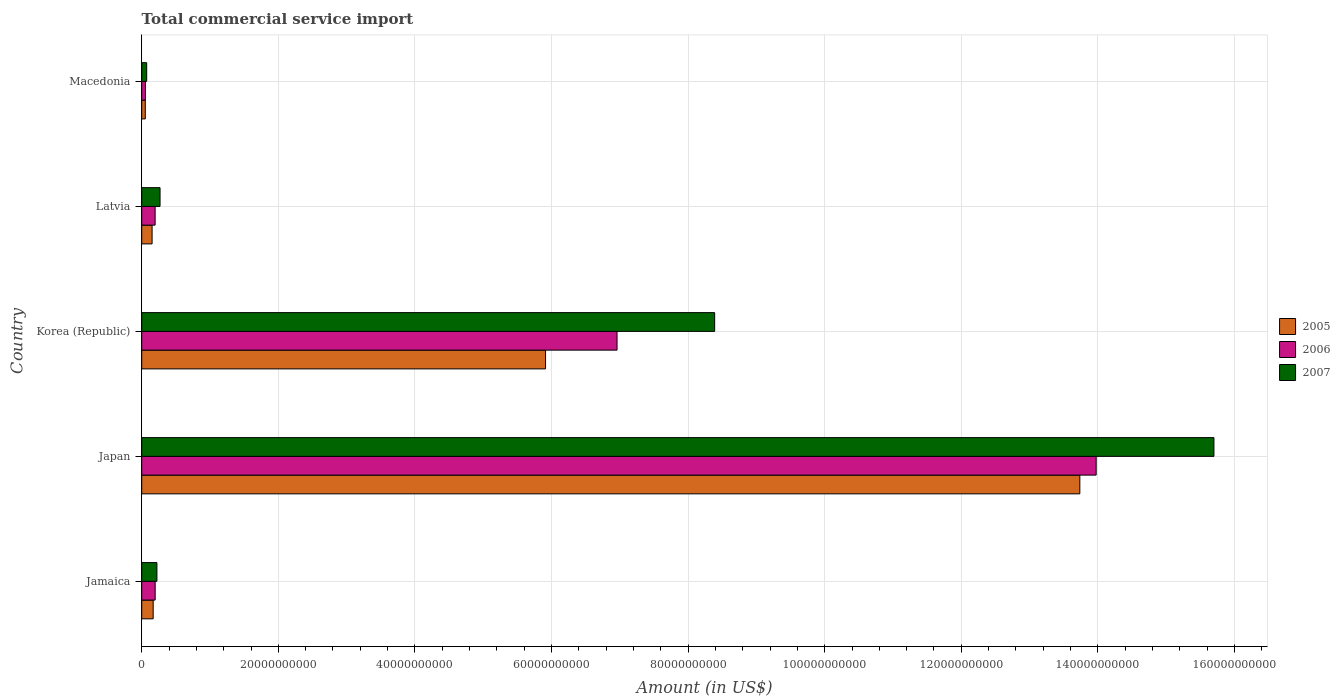How many different coloured bars are there?
Your response must be concise. 3. How many groups of bars are there?
Provide a short and direct response. 5. What is the label of the 4th group of bars from the top?
Provide a short and direct response. Japan. In how many cases, is the number of bars for a given country not equal to the number of legend labels?
Offer a very short reply. 0. What is the total commercial service import in 2006 in Latvia?
Offer a terse response. 1.96e+09. Across all countries, what is the maximum total commercial service import in 2007?
Your answer should be very brief. 1.57e+11. Across all countries, what is the minimum total commercial service import in 2006?
Offer a very short reply. 5.38e+08. In which country was the total commercial service import in 2006 minimum?
Your answer should be compact. Macedonia. What is the total total commercial service import in 2005 in the graph?
Offer a very short reply. 2.00e+11. What is the difference between the total commercial service import in 2007 in Latvia and that in Macedonia?
Keep it short and to the point. 1.95e+09. What is the difference between the total commercial service import in 2007 in Jamaica and the total commercial service import in 2005 in Korea (Republic)?
Provide a succinct answer. -5.69e+1. What is the average total commercial service import in 2007 per country?
Offer a terse response. 4.93e+1. What is the difference between the total commercial service import in 2006 and total commercial service import in 2005 in Jamaica?
Provide a succinct answer. 2.94e+08. In how many countries, is the total commercial service import in 2005 greater than 76000000000 US$?
Your answer should be compact. 1. What is the ratio of the total commercial service import in 2007 in Japan to that in Latvia?
Give a very brief answer. 58.53. Is the difference between the total commercial service import in 2006 in Jamaica and Latvia greater than the difference between the total commercial service import in 2005 in Jamaica and Latvia?
Provide a succinct answer. No. What is the difference between the highest and the second highest total commercial service import in 2005?
Offer a terse response. 7.82e+1. What is the difference between the highest and the lowest total commercial service import in 2005?
Your answer should be very brief. 1.37e+11. In how many countries, is the total commercial service import in 2006 greater than the average total commercial service import in 2006 taken over all countries?
Your answer should be very brief. 2. Is the sum of the total commercial service import in 2006 in Jamaica and Korea (Republic) greater than the maximum total commercial service import in 2007 across all countries?
Offer a terse response. No. Are all the bars in the graph horizontal?
Keep it short and to the point. Yes. How many countries are there in the graph?
Your answer should be compact. 5. What is the difference between two consecutive major ticks on the X-axis?
Offer a very short reply. 2.00e+1. Are the values on the major ticks of X-axis written in scientific E-notation?
Provide a short and direct response. No. Does the graph contain any zero values?
Make the answer very short. No. How many legend labels are there?
Ensure brevity in your answer.  3. What is the title of the graph?
Your answer should be compact. Total commercial service import. Does "1961" appear as one of the legend labels in the graph?
Your answer should be very brief. No. What is the label or title of the X-axis?
Your answer should be very brief. Amount (in US$). What is the Amount (in US$) in 2005 in Jamaica?
Your response must be concise. 1.68e+09. What is the Amount (in US$) in 2006 in Jamaica?
Ensure brevity in your answer.  1.97e+09. What is the Amount (in US$) of 2007 in Jamaica?
Your response must be concise. 2.23e+09. What is the Amount (in US$) of 2005 in Japan?
Offer a very short reply. 1.37e+11. What is the Amount (in US$) of 2006 in Japan?
Give a very brief answer. 1.40e+11. What is the Amount (in US$) in 2007 in Japan?
Offer a terse response. 1.57e+11. What is the Amount (in US$) in 2005 in Korea (Republic)?
Provide a short and direct response. 5.91e+1. What is the Amount (in US$) in 2006 in Korea (Republic)?
Provide a succinct answer. 6.96e+1. What is the Amount (in US$) in 2007 in Korea (Republic)?
Offer a very short reply. 8.39e+1. What is the Amount (in US$) of 2005 in Latvia?
Ensure brevity in your answer.  1.52e+09. What is the Amount (in US$) of 2006 in Latvia?
Offer a terse response. 1.96e+09. What is the Amount (in US$) of 2007 in Latvia?
Keep it short and to the point. 2.68e+09. What is the Amount (in US$) in 2005 in Macedonia?
Your response must be concise. 5.23e+08. What is the Amount (in US$) in 2006 in Macedonia?
Make the answer very short. 5.38e+08. What is the Amount (in US$) of 2007 in Macedonia?
Your response must be concise. 7.27e+08. Across all countries, what is the maximum Amount (in US$) in 2005?
Offer a very short reply. 1.37e+11. Across all countries, what is the maximum Amount (in US$) in 2006?
Your answer should be compact. 1.40e+11. Across all countries, what is the maximum Amount (in US$) in 2007?
Ensure brevity in your answer.  1.57e+11. Across all countries, what is the minimum Amount (in US$) of 2005?
Your answer should be compact. 5.23e+08. Across all countries, what is the minimum Amount (in US$) in 2006?
Offer a terse response. 5.38e+08. Across all countries, what is the minimum Amount (in US$) in 2007?
Offer a terse response. 7.27e+08. What is the total Amount (in US$) of 2005 in the graph?
Offer a terse response. 2.00e+11. What is the total Amount (in US$) in 2006 in the graph?
Give a very brief answer. 2.14e+11. What is the total Amount (in US$) in 2007 in the graph?
Provide a short and direct response. 2.47e+11. What is the difference between the Amount (in US$) in 2005 in Jamaica and that in Japan?
Your answer should be very brief. -1.36e+11. What is the difference between the Amount (in US$) in 2006 in Jamaica and that in Japan?
Your answer should be very brief. -1.38e+11. What is the difference between the Amount (in US$) in 2007 in Jamaica and that in Japan?
Your answer should be compact. -1.55e+11. What is the difference between the Amount (in US$) of 2005 in Jamaica and that in Korea (Republic)?
Offer a terse response. -5.75e+1. What is the difference between the Amount (in US$) of 2006 in Jamaica and that in Korea (Republic)?
Your response must be concise. -6.76e+1. What is the difference between the Amount (in US$) in 2007 in Jamaica and that in Korea (Republic)?
Offer a terse response. -8.17e+1. What is the difference between the Amount (in US$) in 2005 in Jamaica and that in Latvia?
Give a very brief answer. 1.56e+08. What is the difference between the Amount (in US$) of 2006 in Jamaica and that in Latvia?
Ensure brevity in your answer.  7.28e+06. What is the difference between the Amount (in US$) of 2007 in Jamaica and that in Latvia?
Offer a terse response. -4.57e+08. What is the difference between the Amount (in US$) in 2005 in Jamaica and that in Macedonia?
Give a very brief answer. 1.15e+09. What is the difference between the Amount (in US$) in 2006 in Jamaica and that in Macedonia?
Keep it short and to the point. 1.43e+09. What is the difference between the Amount (in US$) of 2007 in Jamaica and that in Macedonia?
Give a very brief answer. 1.50e+09. What is the difference between the Amount (in US$) in 2005 in Japan and that in Korea (Republic)?
Your response must be concise. 7.82e+1. What is the difference between the Amount (in US$) in 2006 in Japan and that in Korea (Republic)?
Your response must be concise. 7.02e+1. What is the difference between the Amount (in US$) in 2007 in Japan and that in Korea (Republic)?
Your answer should be compact. 7.31e+1. What is the difference between the Amount (in US$) in 2005 in Japan and that in Latvia?
Your answer should be very brief. 1.36e+11. What is the difference between the Amount (in US$) of 2006 in Japan and that in Latvia?
Make the answer very short. 1.38e+11. What is the difference between the Amount (in US$) of 2007 in Japan and that in Latvia?
Your answer should be very brief. 1.54e+11. What is the difference between the Amount (in US$) in 2005 in Japan and that in Macedonia?
Keep it short and to the point. 1.37e+11. What is the difference between the Amount (in US$) in 2006 in Japan and that in Macedonia?
Offer a terse response. 1.39e+11. What is the difference between the Amount (in US$) of 2007 in Japan and that in Macedonia?
Keep it short and to the point. 1.56e+11. What is the difference between the Amount (in US$) in 2005 in Korea (Republic) and that in Latvia?
Provide a short and direct response. 5.76e+1. What is the difference between the Amount (in US$) in 2006 in Korea (Republic) and that in Latvia?
Offer a very short reply. 6.76e+1. What is the difference between the Amount (in US$) in 2007 in Korea (Republic) and that in Latvia?
Provide a short and direct response. 8.12e+1. What is the difference between the Amount (in US$) in 2005 in Korea (Republic) and that in Macedonia?
Your answer should be very brief. 5.86e+1. What is the difference between the Amount (in US$) of 2006 in Korea (Republic) and that in Macedonia?
Ensure brevity in your answer.  6.91e+1. What is the difference between the Amount (in US$) of 2007 in Korea (Republic) and that in Macedonia?
Ensure brevity in your answer.  8.32e+1. What is the difference between the Amount (in US$) in 2005 in Latvia and that in Macedonia?
Provide a succinct answer. 9.97e+08. What is the difference between the Amount (in US$) of 2006 in Latvia and that in Macedonia?
Offer a terse response. 1.42e+09. What is the difference between the Amount (in US$) in 2007 in Latvia and that in Macedonia?
Offer a very short reply. 1.95e+09. What is the difference between the Amount (in US$) in 2005 in Jamaica and the Amount (in US$) in 2006 in Japan?
Make the answer very short. -1.38e+11. What is the difference between the Amount (in US$) in 2005 in Jamaica and the Amount (in US$) in 2007 in Japan?
Offer a very short reply. -1.55e+11. What is the difference between the Amount (in US$) in 2006 in Jamaica and the Amount (in US$) in 2007 in Japan?
Offer a terse response. -1.55e+11. What is the difference between the Amount (in US$) of 2005 in Jamaica and the Amount (in US$) of 2006 in Korea (Republic)?
Your answer should be very brief. -6.79e+1. What is the difference between the Amount (in US$) in 2005 in Jamaica and the Amount (in US$) in 2007 in Korea (Republic)?
Your response must be concise. -8.22e+1. What is the difference between the Amount (in US$) in 2006 in Jamaica and the Amount (in US$) in 2007 in Korea (Republic)?
Your response must be concise. -8.19e+1. What is the difference between the Amount (in US$) of 2005 in Jamaica and the Amount (in US$) of 2006 in Latvia?
Your answer should be compact. -2.87e+08. What is the difference between the Amount (in US$) in 2005 in Jamaica and the Amount (in US$) in 2007 in Latvia?
Your answer should be very brief. -1.01e+09. What is the difference between the Amount (in US$) in 2006 in Jamaica and the Amount (in US$) in 2007 in Latvia?
Your answer should be very brief. -7.13e+08. What is the difference between the Amount (in US$) in 2005 in Jamaica and the Amount (in US$) in 2006 in Macedonia?
Provide a succinct answer. 1.14e+09. What is the difference between the Amount (in US$) in 2005 in Jamaica and the Amount (in US$) in 2007 in Macedonia?
Provide a short and direct response. 9.48e+08. What is the difference between the Amount (in US$) of 2006 in Jamaica and the Amount (in US$) of 2007 in Macedonia?
Keep it short and to the point. 1.24e+09. What is the difference between the Amount (in US$) in 2005 in Japan and the Amount (in US$) in 2006 in Korea (Republic)?
Ensure brevity in your answer.  6.78e+1. What is the difference between the Amount (in US$) of 2005 in Japan and the Amount (in US$) of 2007 in Korea (Republic)?
Provide a succinct answer. 5.35e+1. What is the difference between the Amount (in US$) of 2006 in Japan and the Amount (in US$) of 2007 in Korea (Republic)?
Ensure brevity in your answer.  5.59e+1. What is the difference between the Amount (in US$) in 2005 in Japan and the Amount (in US$) in 2006 in Latvia?
Your answer should be very brief. 1.35e+11. What is the difference between the Amount (in US$) of 2005 in Japan and the Amount (in US$) of 2007 in Latvia?
Provide a succinct answer. 1.35e+11. What is the difference between the Amount (in US$) of 2006 in Japan and the Amount (in US$) of 2007 in Latvia?
Ensure brevity in your answer.  1.37e+11. What is the difference between the Amount (in US$) of 2005 in Japan and the Amount (in US$) of 2006 in Macedonia?
Make the answer very short. 1.37e+11. What is the difference between the Amount (in US$) of 2005 in Japan and the Amount (in US$) of 2007 in Macedonia?
Your answer should be compact. 1.37e+11. What is the difference between the Amount (in US$) of 2006 in Japan and the Amount (in US$) of 2007 in Macedonia?
Provide a short and direct response. 1.39e+11. What is the difference between the Amount (in US$) of 2005 in Korea (Republic) and the Amount (in US$) of 2006 in Latvia?
Your answer should be compact. 5.72e+1. What is the difference between the Amount (in US$) in 2005 in Korea (Republic) and the Amount (in US$) in 2007 in Latvia?
Your response must be concise. 5.64e+1. What is the difference between the Amount (in US$) in 2006 in Korea (Republic) and the Amount (in US$) in 2007 in Latvia?
Provide a succinct answer. 6.69e+1. What is the difference between the Amount (in US$) of 2005 in Korea (Republic) and the Amount (in US$) of 2006 in Macedonia?
Offer a terse response. 5.86e+1. What is the difference between the Amount (in US$) in 2005 in Korea (Republic) and the Amount (in US$) in 2007 in Macedonia?
Give a very brief answer. 5.84e+1. What is the difference between the Amount (in US$) of 2006 in Korea (Republic) and the Amount (in US$) of 2007 in Macedonia?
Give a very brief answer. 6.89e+1. What is the difference between the Amount (in US$) in 2005 in Latvia and the Amount (in US$) in 2006 in Macedonia?
Offer a terse response. 9.81e+08. What is the difference between the Amount (in US$) of 2005 in Latvia and the Amount (in US$) of 2007 in Macedonia?
Offer a terse response. 7.92e+08. What is the difference between the Amount (in US$) of 2006 in Latvia and the Amount (in US$) of 2007 in Macedonia?
Your answer should be very brief. 1.23e+09. What is the average Amount (in US$) in 2005 per country?
Ensure brevity in your answer.  4.00e+1. What is the average Amount (in US$) in 2006 per country?
Provide a short and direct response. 4.28e+1. What is the average Amount (in US$) of 2007 per country?
Your answer should be very brief. 4.93e+1. What is the difference between the Amount (in US$) in 2005 and Amount (in US$) in 2006 in Jamaica?
Your response must be concise. -2.94e+08. What is the difference between the Amount (in US$) in 2005 and Amount (in US$) in 2007 in Jamaica?
Offer a terse response. -5.50e+08. What is the difference between the Amount (in US$) in 2006 and Amount (in US$) in 2007 in Jamaica?
Offer a very short reply. -2.56e+08. What is the difference between the Amount (in US$) of 2005 and Amount (in US$) of 2006 in Japan?
Give a very brief answer. -2.39e+09. What is the difference between the Amount (in US$) in 2005 and Amount (in US$) in 2007 in Japan?
Ensure brevity in your answer.  -1.96e+1. What is the difference between the Amount (in US$) in 2006 and Amount (in US$) in 2007 in Japan?
Provide a short and direct response. -1.72e+1. What is the difference between the Amount (in US$) of 2005 and Amount (in US$) of 2006 in Korea (Republic)?
Make the answer very short. -1.05e+1. What is the difference between the Amount (in US$) of 2005 and Amount (in US$) of 2007 in Korea (Republic)?
Keep it short and to the point. -2.48e+1. What is the difference between the Amount (in US$) in 2006 and Amount (in US$) in 2007 in Korea (Republic)?
Provide a succinct answer. -1.43e+1. What is the difference between the Amount (in US$) in 2005 and Amount (in US$) in 2006 in Latvia?
Your answer should be compact. -4.42e+08. What is the difference between the Amount (in US$) in 2005 and Amount (in US$) in 2007 in Latvia?
Make the answer very short. -1.16e+09. What is the difference between the Amount (in US$) in 2006 and Amount (in US$) in 2007 in Latvia?
Offer a terse response. -7.20e+08. What is the difference between the Amount (in US$) of 2005 and Amount (in US$) of 2006 in Macedonia?
Your answer should be compact. -1.52e+07. What is the difference between the Amount (in US$) in 2005 and Amount (in US$) in 2007 in Macedonia?
Provide a succinct answer. -2.04e+08. What is the difference between the Amount (in US$) of 2006 and Amount (in US$) of 2007 in Macedonia?
Give a very brief answer. -1.89e+08. What is the ratio of the Amount (in US$) of 2005 in Jamaica to that in Japan?
Keep it short and to the point. 0.01. What is the ratio of the Amount (in US$) in 2006 in Jamaica to that in Japan?
Provide a succinct answer. 0.01. What is the ratio of the Amount (in US$) in 2007 in Jamaica to that in Japan?
Your response must be concise. 0.01. What is the ratio of the Amount (in US$) of 2005 in Jamaica to that in Korea (Republic)?
Provide a succinct answer. 0.03. What is the ratio of the Amount (in US$) of 2006 in Jamaica to that in Korea (Republic)?
Provide a succinct answer. 0.03. What is the ratio of the Amount (in US$) in 2007 in Jamaica to that in Korea (Republic)?
Your answer should be very brief. 0.03. What is the ratio of the Amount (in US$) of 2005 in Jamaica to that in Latvia?
Provide a succinct answer. 1.1. What is the ratio of the Amount (in US$) of 2007 in Jamaica to that in Latvia?
Provide a short and direct response. 0.83. What is the ratio of the Amount (in US$) in 2005 in Jamaica to that in Macedonia?
Provide a succinct answer. 3.2. What is the ratio of the Amount (in US$) in 2006 in Jamaica to that in Macedonia?
Your answer should be very brief. 3.66. What is the ratio of the Amount (in US$) of 2007 in Jamaica to that in Macedonia?
Provide a short and direct response. 3.06. What is the ratio of the Amount (in US$) in 2005 in Japan to that in Korea (Republic)?
Keep it short and to the point. 2.32. What is the ratio of the Amount (in US$) in 2006 in Japan to that in Korea (Republic)?
Offer a very short reply. 2.01. What is the ratio of the Amount (in US$) of 2007 in Japan to that in Korea (Republic)?
Offer a terse response. 1.87. What is the ratio of the Amount (in US$) of 2005 in Japan to that in Latvia?
Make the answer very short. 90.38. What is the ratio of the Amount (in US$) in 2006 in Japan to that in Latvia?
Your answer should be compact. 71.22. What is the ratio of the Amount (in US$) in 2007 in Japan to that in Latvia?
Your response must be concise. 58.53. What is the ratio of the Amount (in US$) in 2005 in Japan to that in Macedonia?
Your answer should be compact. 262.58. What is the ratio of the Amount (in US$) of 2006 in Japan to that in Macedonia?
Provide a short and direct response. 259.6. What is the ratio of the Amount (in US$) of 2007 in Japan to that in Macedonia?
Ensure brevity in your answer.  215.83. What is the ratio of the Amount (in US$) of 2005 in Korea (Republic) to that in Latvia?
Keep it short and to the point. 38.91. What is the ratio of the Amount (in US$) of 2006 in Korea (Republic) to that in Latvia?
Give a very brief answer. 35.47. What is the ratio of the Amount (in US$) of 2007 in Korea (Republic) to that in Latvia?
Offer a terse response. 31.27. What is the ratio of the Amount (in US$) in 2005 in Korea (Republic) to that in Macedonia?
Your response must be concise. 113.03. What is the ratio of the Amount (in US$) in 2006 in Korea (Republic) to that in Macedonia?
Your answer should be very brief. 129.28. What is the ratio of the Amount (in US$) in 2007 in Korea (Republic) to that in Macedonia?
Ensure brevity in your answer.  115.33. What is the ratio of the Amount (in US$) in 2005 in Latvia to that in Macedonia?
Your response must be concise. 2.91. What is the ratio of the Amount (in US$) of 2006 in Latvia to that in Macedonia?
Keep it short and to the point. 3.65. What is the ratio of the Amount (in US$) in 2007 in Latvia to that in Macedonia?
Give a very brief answer. 3.69. What is the difference between the highest and the second highest Amount (in US$) of 2005?
Ensure brevity in your answer.  7.82e+1. What is the difference between the highest and the second highest Amount (in US$) of 2006?
Make the answer very short. 7.02e+1. What is the difference between the highest and the second highest Amount (in US$) of 2007?
Keep it short and to the point. 7.31e+1. What is the difference between the highest and the lowest Amount (in US$) in 2005?
Ensure brevity in your answer.  1.37e+11. What is the difference between the highest and the lowest Amount (in US$) of 2006?
Your response must be concise. 1.39e+11. What is the difference between the highest and the lowest Amount (in US$) of 2007?
Offer a terse response. 1.56e+11. 